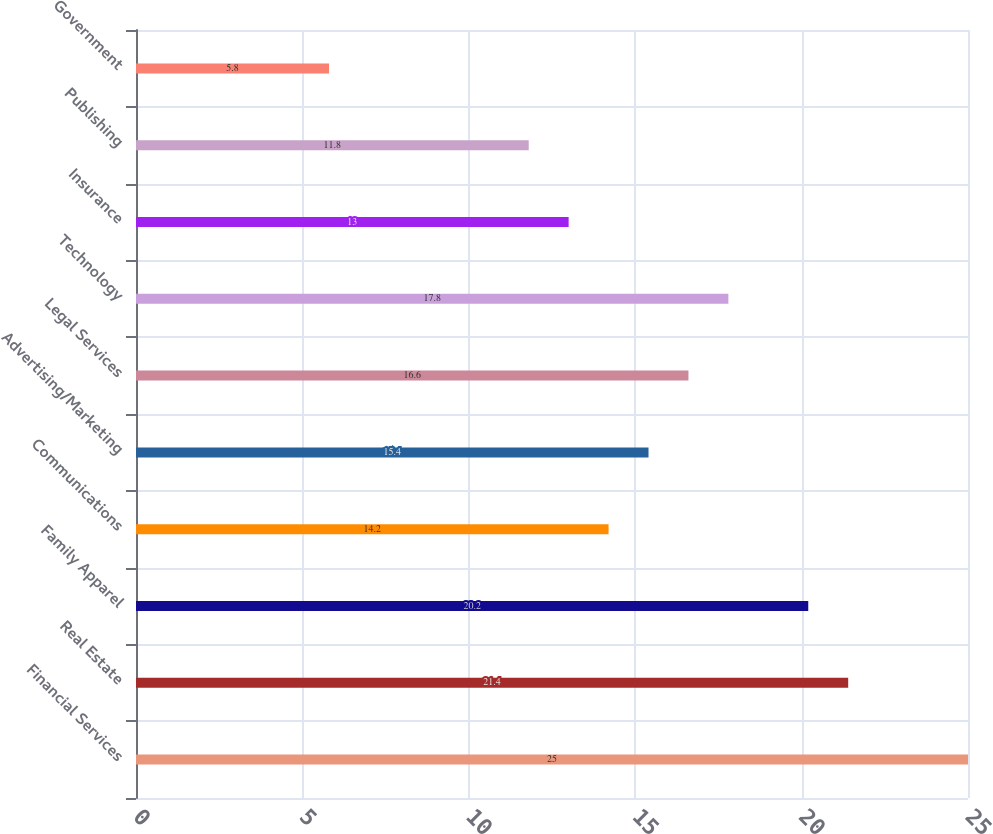Convert chart. <chart><loc_0><loc_0><loc_500><loc_500><bar_chart><fcel>Financial Services<fcel>Real Estate<fcel>Family Apparel<fcel>Communications<fcel>Advertising/Marketing<fcel>Legal Services<fcel>Technology<fcel>Insurance<fcel>Publishing<fcel>Government<nl><fcel>25<fcel>21.4<fcel>20.2<fcel>14.2<fcel>15.4<fcel>16.6<fcel>17.8<fcel>13<fcel>11.8<fcel>5.8<nl></chart> 